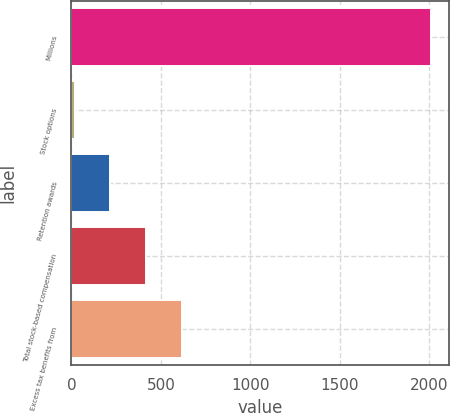Convert chart. <chart><loc_0><loc_0><loc_500><loc_500><bar_chart><fcel>Millions<fcel>Stock options<fcel>Retention awards<fcel>Total stock-based compensation<fcel>Excess tax benefits from<nl><fcel>2011<fcel>18<fcel>217.3<fcel>416.6<fcel>615.9<nl></chart> 